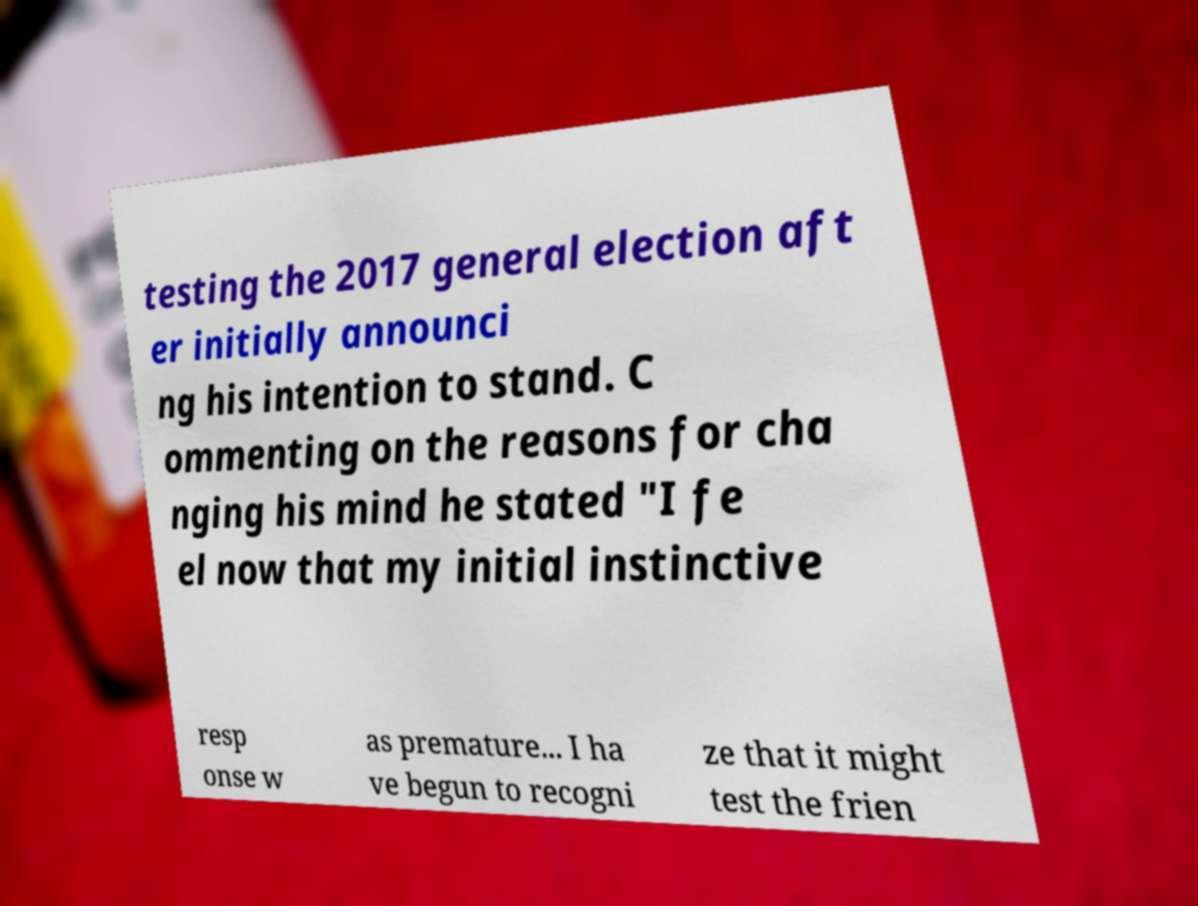Could you assist in decoding the text presented in this image and type it out clearly? testing the 2017 general election aft er initially announci ng his intention to stand. C ommenting on the reasons for cha nging his mind he stated "I fe el now that my initial instinctive resp onse w as premature... I ha ve begun to recogni ze that it might test the frien 